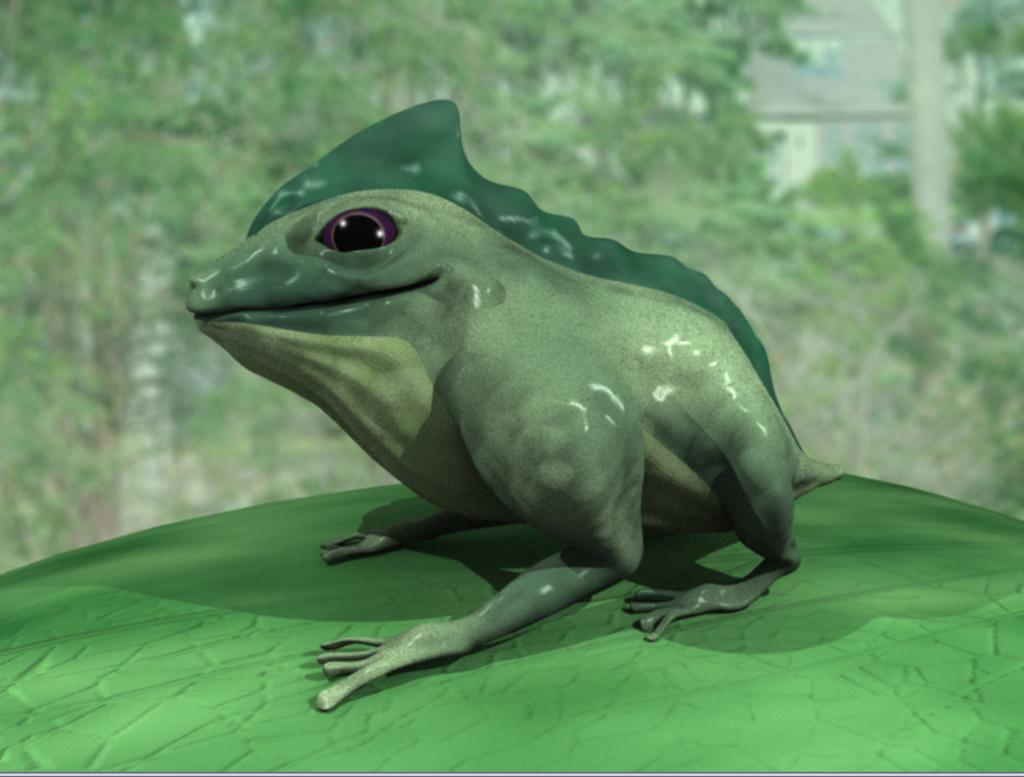What type of image is being described? The image is animated. What animal is present in the image? There is a frog in the image. How is the background of the frog depicted? The background of the frog is blurred. What type of dirt can be seen on the frog's back in the image? There is no dirt visible on the frog's back in the image. How does the steam affect the frog's movements in the image? There is no steam present in the image, so it does not affect the frog's movements. 